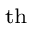Convert formula to latex. <formula><loc_0><loc_0><loc_500><loc_500>^ { t } h</formula> 